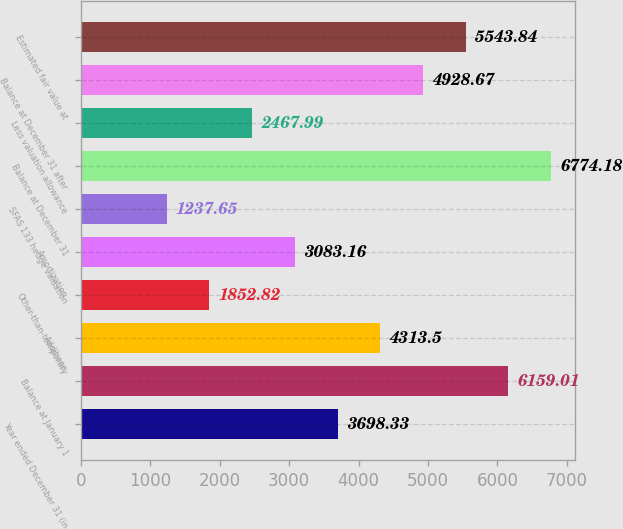<chart> <loc_0><loc_0><loc_500><loc_500><bar_chart><fcel>Year ended December 31 (in<fcel>Balance at January 1<fcel>Additions<fcel>Other-than-temporary<fcel>Amortization<fcel>SFAS 133 hedge valuation<fcel>Balance at December 31<fcel>Less valuation allowance<fcel>Balance at December 31 after<fcel>Estimated fair value at<nl><fcel>3698.33<fcel>6159.01<fcel>4313.5<fcel>1852.82<fcel>3083.16<fcel>1237.65<fcel>6774.18<fcel>2467.99<fcel>4928.67<fcel>5543.84<nl></chart> 